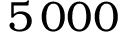Convert formula to latex. <formula><loc_0><loc_0><loc_500><loc_500>5 \, 0 0 0</formula> 